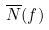Convert formula to latex. <formula><loc_0><loc_0><loc_500><loc_500>\overline { N } ( f )</formula> 